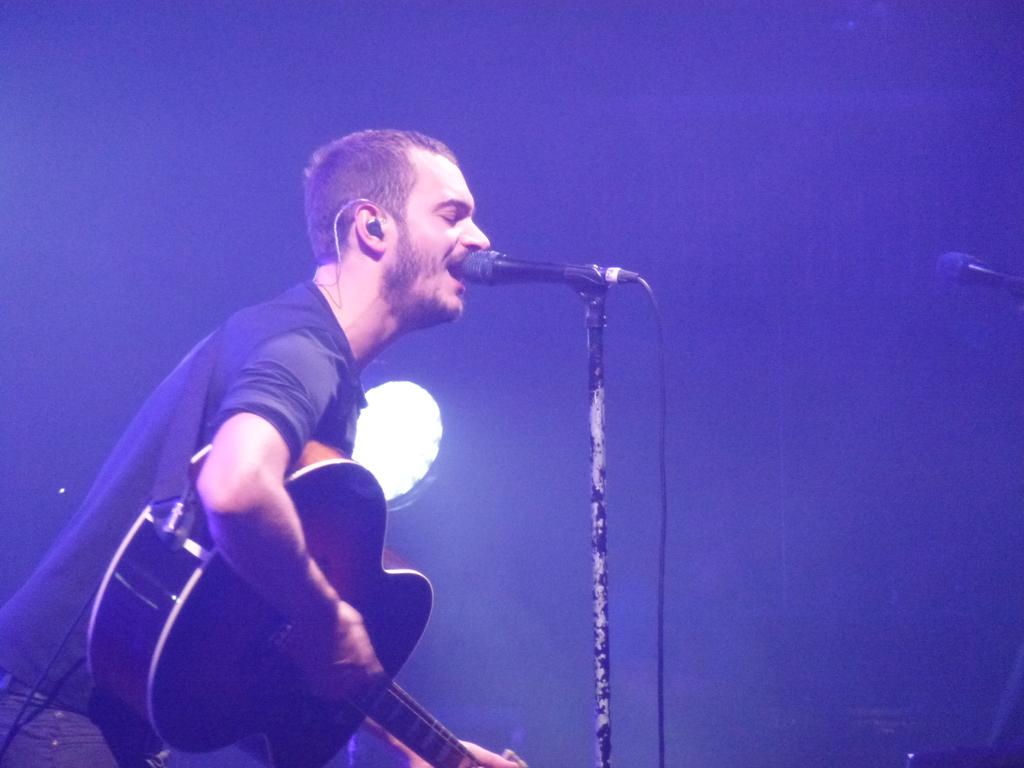What is the person in the image doing? The person is holding a guitar and singing. What object is the person using to amplify their voice? There is a microphone in the image. Is the person driving a car while holding the guitar in the image? No, there is no car or driving activity present in the image. 